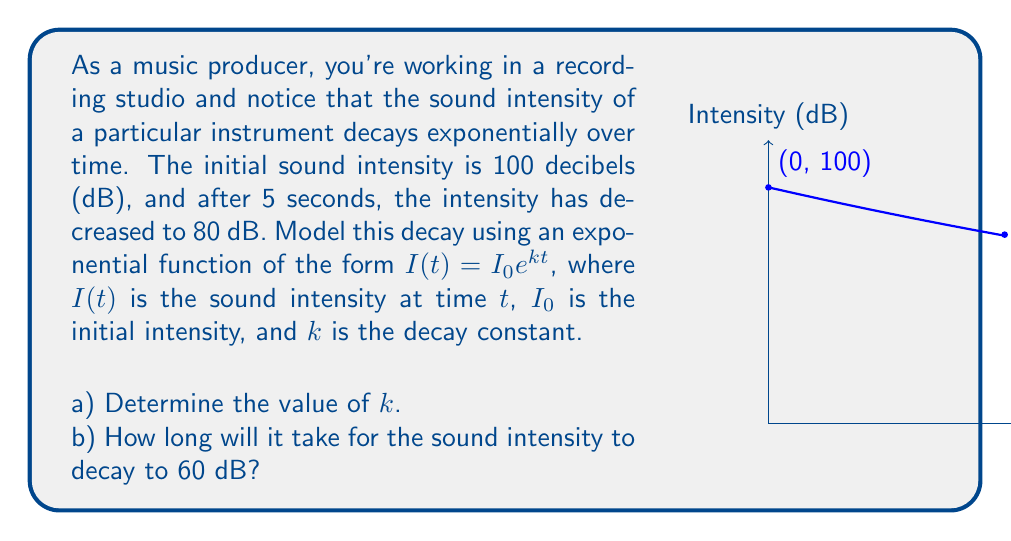Teach me how to tackle this problem. Let's approach this problem step by step:

a) To find $k$, we'll use the given information:
   $I_0 = 100$ dB (initial intensity)
   $I(5) = 80$ dB (intensity after 5 seconds)

   Plugging these into the equation $I(t) = I_0 e^{kt}$:
   
   $80 = 100e^{5k}$

   Dividing both sides by 100:
   
   $0.8 = e^{5k}$

   Taking the natural log of both sides:
   
   $\ln(0.8) = 5k$

   Solving for $k$:
   
   $k = \frac{\ln(0.8)}{5} \approx -0.04576$ s⁻¹

b) To find the time when the intensity reaches 60 dB, we use the equation with our found $k$ value:

   $60 = 100e^{-0.04576t}$

   Dividing both sides by 100:
   
   $0.6 = e^{-0.04576t}$

   Taking the natural log of both sides:
   
   $\ln(0.6) = -0.04576t$

   Solving for $t$:
   
   $t = \frac{\ln(0.6)}{-0.04576} \approx 11.24$ seconds
Answer: a) $k \approx -0.04576$ s⁻¹
b) $t \approx 11.24$ seconds 